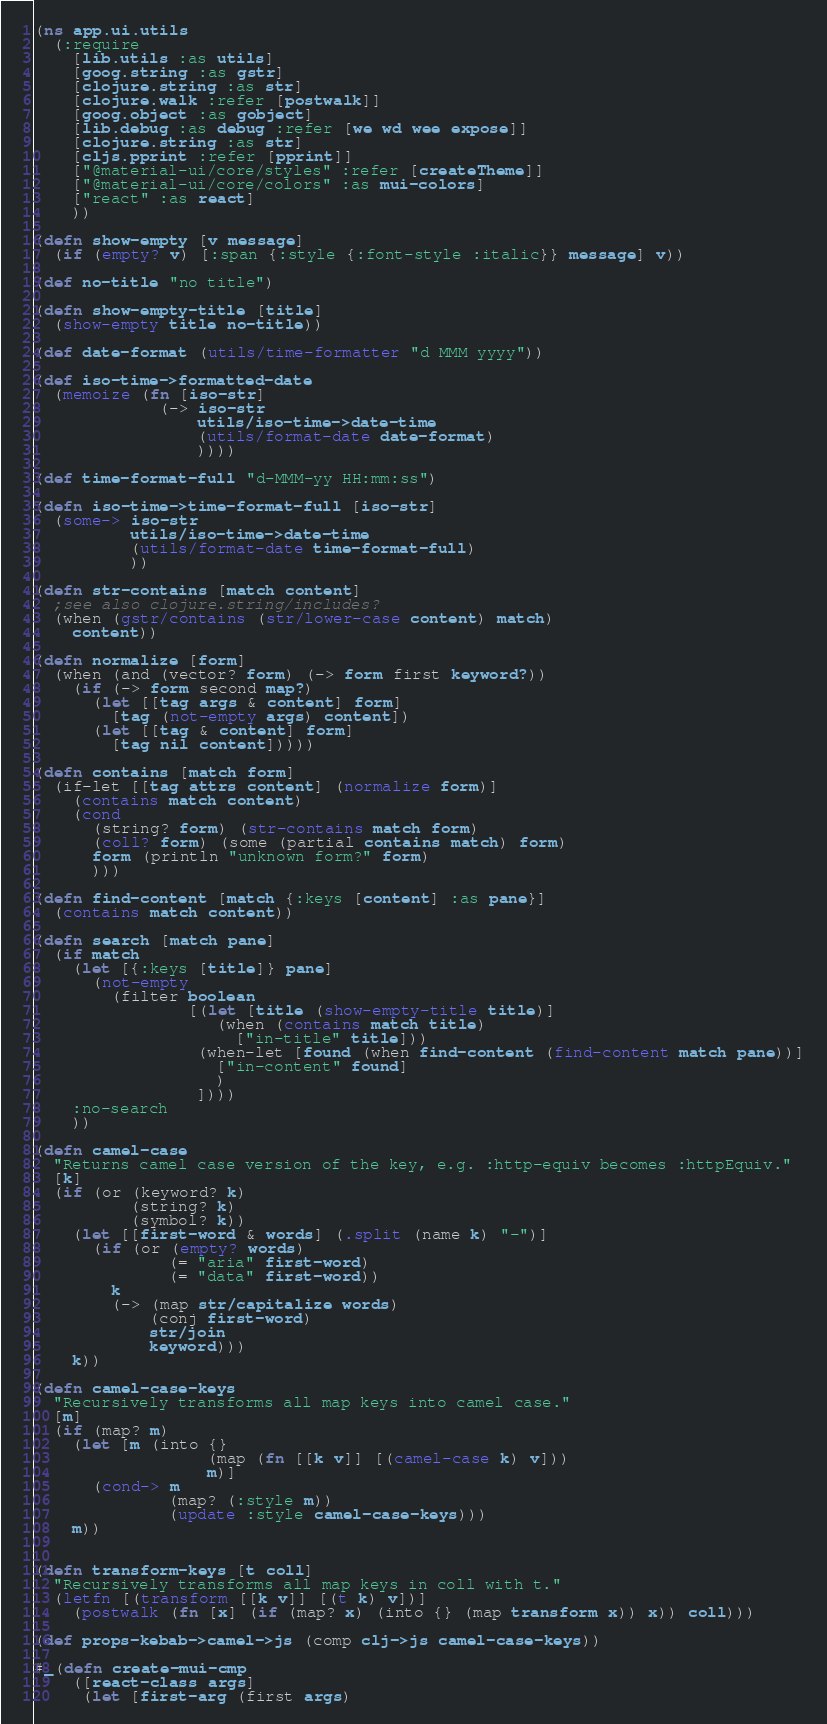Convert code to text. <code><loc_0><loc_0><loc_500><loc_500><_Clojure_>(ns app.ui.utils
  (:require
    [lib.utils :as utils]
    [goog.string :as gstr]
    [clojure.string :as str]
    [clojure.walk :refer [postwalk]]
    [goog.object :as gobject]
    [lib.debug :as debug :refer [we wd wee expose]]
    [clojure.string :as str]
    [cljs.pprint :refer [pprint]]
    ["@material-ui/core/styles" :refer [createTheme]]
    ["@material-ui/core/colors" :as mui-colors]
    ["react" :as react]
    ))

(defn show-empty [v message]
  (if (empty? v) [:span {:style {:font-style :italic}} message] v))

(def no-title "no title")

(defn show-empty-title [title]
  (show-empty title no-title))

(def date-format (utils/time-formatter "d MMM yyyy"))

(def iso-time->formatted-date
  (memoize (fn [iso-str]
             (-> iso-str
                 utils/iso-time->date-time
                 (utils/format-date date-format)
                 ))))

(def time-format-full "d-MMM-yy HH:mm:ss")

(defn iso-time->time-format-full [iso-str]
  (some-> iso-str
          utils/iso-time->date-time
          (utils/format-date time-format-full)
          ))

(defn str-contains [match content]
  ;see also clojure.string/includes?
  (when (gstr/contains (str/lower-case content) match)
    content))

(defn normalize [form]
  (when (and (vector? form) (-> form first keyword?))
    (if (-> form second map?)
      (let [[tag args & content] form]
        [tag (not-empty args) content])
      (let [[tag & content] form]
        [tag nil content]))))

(defn contains [match form]
  (if-let [[tag attrs content] (normalize form)]
    (contains match content)
    (cond
      (string? form) (str-contains match form)
      (coll? form) (some (partial contains match) form)
      form (println "unknown form?" form)
      )))

(defn find-content [match {:keys [content] :as pane}]
  (contains match content))

(defn search [match pane]
  (if match
    (let [{:keys [title]} pane]
      (not-empty
        (filter boolean
                [(let [title (show-empty-title title)]
                   (when (contains match title)
                     ["in-title" title]))
                 (when-let [found (when find-content (find-content match pane))]
                   ["in-content" found]
                   )
                 ])))
    :no-search
    ))

(defn camel-case
  "Returns camel case version of the key, e.g. :http-equiv becomes :httpEquiv."
  [k]
  (if (or (keyword? k)
          (string? k)
          (symbol? k))
    (let [[first-word & words] (.split (name k) "-")]
      (if (or (empty? words)
              (= "aria" first-word)
              (= "data" first-word))
        k
        (-> (map str/capitalize words)
            (conj first-word)
            str/join
            keyword)))
    k))

(defn camel-case-keys
  "Recursively transforms all map keys into camel case."
  [m]
  (if (map? m)
    (let [m (into {}
                  (map (fn [[k v]] [(camel-case k) v]))
                  m)]
      (cond-> m
              (map? (:style m))
              (update :style camel-case-keys)))
    m))


(defn transform-keys [t coll]
  "Recursively transforms all map keys in coll with t."
  (letfn [(transform [[k v]] [(t k) v])]
    (postwalk (fn [x] (if (map? x) (into {} (map transform x)) x)) coll)))

(def props-kebab->camel->js (comp clj->js camel-case-keys))

#_(defn create-mui-cmp
    ([react-class args]
     (let [first-arg (first args)</code> 